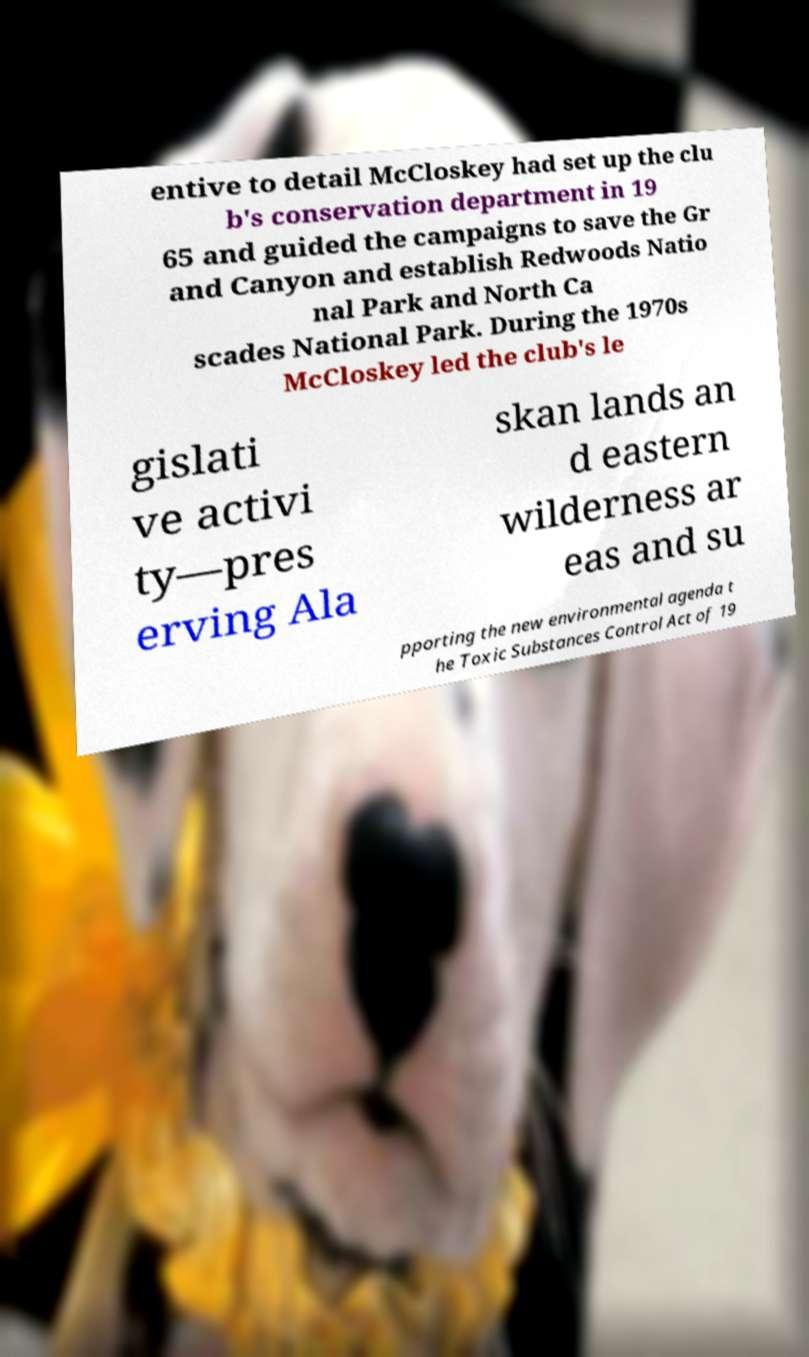Please read and relay the text visible in this image. What does it say? entive to detail McCloskey had set up the clu b's conservation department in 19 65 and guided the campaigns to save the Gr and Canyon and establish Redwoods Natio nal Park and North Ca scades National Park. During the 1970s McCloskey led the club's le gislati ve activi ty—pres erving Ala skan lands an d eastern wilderness ar eas and su pporting the new environmental agenda t he Toxic Substances Control Act of 19 